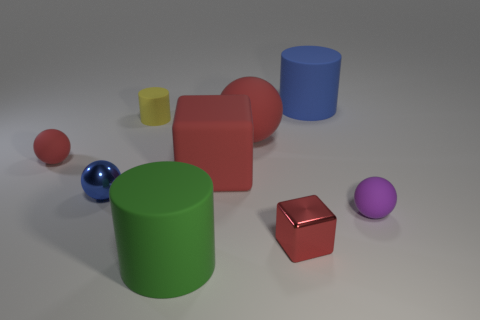Subtract all cylinders. How many objects are left? 6 Subtract all gray cylinders. Subtract all rubber cylinders. How many objects are left? 6 Add 1 small cylinders. How many small cylinders are left? 2 Add 2 yellow matte balls. How many yellow matte balls exist? 2 Subtract 1 red spheres. How many objects are left? 8 